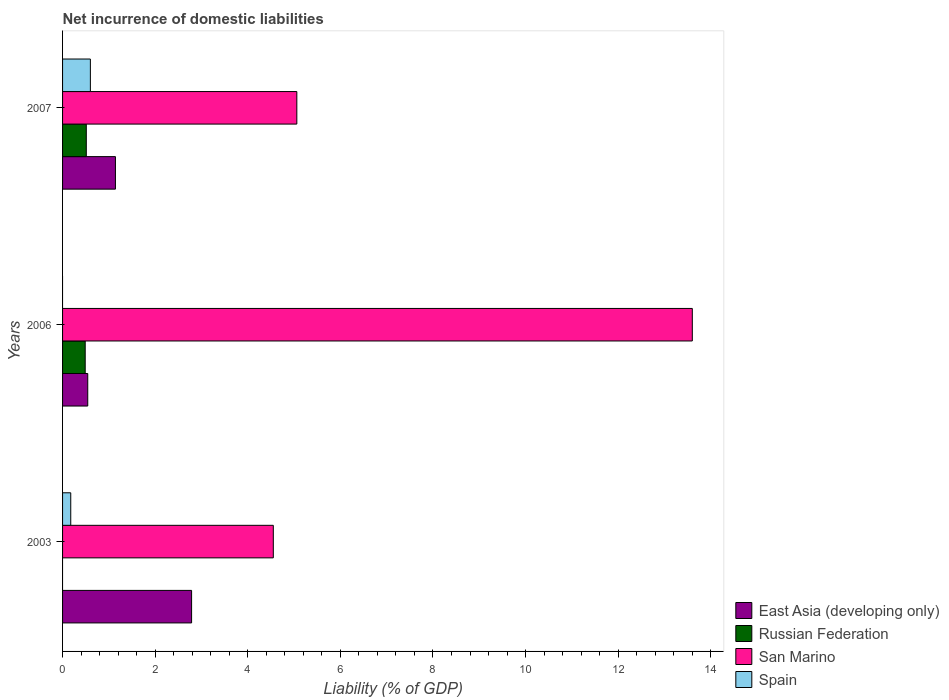How many different coloured bars are there?
Ensure brevity in your answer.  4. How many groups of bars are there?
Provide a short and direct response. 3. In how many cases, is the number of bars for a given year not equal to the number of legend labels?
Your answer should be very brief. 2. What is the net incurrence of domestic liabilities in San Marino in 2006?
Ensure brevity in your answer.  13.6. Across all years, what is the maximum net incurrence of domestic liabilities in Russian Federation?
Offer a terse response. 0.51. Across all years, what is the minimum net incurrence of domestic liabilities in San Marino?
Your answer should be very brief. 4.55. What is the total net incurrence of domestic liabilities in Russian Federation in the graph?
Your answer should be compact. 1. What is the difference between the net incurrence of domestic liabilities in Spain in 2003 and that in 2007?
Give a very brief answer. -0.42. What is the difference between the net incurrence of domestic liabilities in East Asia (developing only) in 2006 and the net incurrence of domestic liabilities in Russian Federation in 2007?
Your answer should be very brief. 0.03. What is the average net incurrence of domestic liabilities in East Asia (developing only) per year?
Offer a very short reply. 1.49. In the year 2006, what is the difference between the net incurrence of domestic liabilities in San Marino and net incurrence of domestic liabilities in Russian Federation?
Your response must be concise. 13.11. What is the ratio of the net incurrence of domestic liabilities in East Asia (developing only) in 2003 to that in 2006?
Make the answer very short. 5.12. Is the net incurrence of domestic liabilities in San Marino in 2003 less than that in 2006?
Your answer should be compact. Yes. Is the difference between the net incurrence of domestic liabilities in San Marino in 2006 and 2007 greater than the difference between the net incurrence of domestic liabilities in Russian Federation in 2006 and 2007?
Your answer should be very brief. Yes. What is the difference between the highest and the second highest net incurrence of domestic liabilities in San Marino?
Offer a terse response. 8.54. What is the difference between the highest and the lowest net incurrence of domestic liabilities in Russian Federation?
Ensure brevity in your answer.  0.51. In how many years, is the net incurrence of domestic liabilities in San Marino greater than the average net incurrence of domestic liabilities in San Marino taken over all years?
Make the answer very short. 1. Is the sum of the net incurrence of domestic liabilities in San Marino in 2003 and 2007 greater than the maximum net incurrence of domestic liabilities in Spain across all years?
Give a very brief answer. Yes. Are all the bars in the graph horizontal?
Provide a succinct answer. Yes. Are the values on the major ticks of X-axis written in scientific E-notation?
Make the answer very short. No. Where does the legend appear in the graph?
Ensure brevity in your answer.  Bottom right. How many legend labels are there?
Make the answer very short. 4. What is the title of the graph?
Give a very brief answer. Net incurrence of domestic liabilities. Does "Cambodia" appear as one of the legend labels in the graph?
Keep it short and to the point. No. What is the label or title of the X-axis?
Your answer should be compact. Liability (% of GDP). What is the Liability (% of GDP) of East Asia (developing only) in 2003?
Your answer should be compact. 2.79. What is the Liability (% of GDP) in San Marino in 2003?
Keep it short and to the point. 4.55. What is the Liability (% of GDP) of Spain in 2003?
Provide a succinct answer. 0.18. What is the Liability (% of GDP) of East Asia (developing only) in 2006?
Make the answer very short. 0.54. What is the Liability (% of GDP) of Russian Federation in 2006?
Your response must be concise. 0.49. What is the Liability (% of GDP) in San Marino in 2006?
Offer a terse response. 13.6. What is the Liability (% of GDP) of Spain in 2006?
Your response must be concise. 0. What is the Liability (% of GDP) of East Asia (developing only) in 2007?
Offer a terse response. 1.14. What is the Liability (% of GDP) of Russian Federation in 2007?
Your answer should be very brief. 0.51. What is the Liability (% of GDP) of San Marino in 2007?
Provide a succinct answer. 5.06. What is the Liability (% of GDP) in Spain in 2007?
Offer a very short reply. 0.6. Across all years, what is the maximum Liability (% of GDP) in East Asia (developing only)?
Your answer should be very brief. 2.79. Across all years, what is the maximum Liability (% of GDP) of Russian Federation?
Your response must be concise. 0.51. Across all years, what is the maximum Liability (% of GDP) in San Marino?
Your response must be concise. 13.6. Across all years, what is the maximum Liability (% of GDP) in Spain?
Keep it short and to the point. 0.6. Across all years, what is the minimum Liability (% of GDP) in East Asia (developing only)?
Keep it short and to the point. 0.54. Across all years, what is the minimum Liability (% of GDP) of Russian Federation?
Offer a very short reply. 0. Across all years, what is the minimum Liability (% of GDP) of San Marino?
Make the answer very short. 4.55. What is the total Liability (% of GDP) in East Asia (developing only) in the graph?
Make the answer very short. 4.47. What is the total Liability (% of GDP) in San Marino in the graph?
Ensure brevity in your answer.  23.21. What is the total Liability (% of GDP) in Spain in the graph?
Your answer should be compact. 0.78. What is the difference between the Liability (% of GDP) of East Asia (developing only) in 2003 and that in 2006?
Give a very brief answer. 2.24. What is the difference between the Liability (% of GDP) in San Marino in 2003 and that in 2006?
Ensure brevity in your answer.  -9.05. What is the difference between the Liability (% of GDP) of East Asia (developing only) in 2003 and that in 2007?
Offer a very short reply. 1.64. What is the difference between the Liability (% of GDP) in San Marino in 2003 and that in 2007?
Provide a short and direct response. -0.51. What is the difference between the Liability (% of GDP) in Spain in 2003 and that in 2007?
Keep it short and to the point. -0.42. What is the difference between the Liability (% of GDP) in East Asia (developing only) in 2006 and that in 2007?
Offer a terse response. -0.6. What is the difference between the Liability (% of GDP) in Russian Federation in 2006 and that in 2007?
Keep it short and to the point. -0.02. What is the difference between the Liability (% of GDP) in San Marino in 2006 and that in 2007?
Ensure brevity in your answer.  8.54. What is the difference between the Liability (% of GDP) of East Asia (developing only) in 2003 and the Liability (% of GDP) of Russian Federation in 2006?
Ensure brevity in your answer.  2.3. What is the difference between the Liability (% of GDP) of East Asia (developing only) in 2003 and the Liability (% of GDP) of San Marino in 2006?
Provide a succinct answer. -10.81. What is the difference between the Liability (% of GDP) in East Asia (developing only) in 2003 and the Liability (% of GDP) in Russian Federation in 2007?
Give a very brief answer. 2.27. What is the difference between the Liability (% of GDP) in East Asia (developing only) in 2003 and the Liability (% of GDP) in San Marino in 2007?
Provide a short and direct response. -2.27. What is the difference between the Liability (% of GDP) in East Asia (developing only) in 2003 and the Liability (% of GDP) in Spain in 2007?
Your answer should be compact. 2.19. What is the difference between the Liability (% of GDP) of San Marino in 2003 and the Liability (% of GDP) of Spain in 2007?
Your answer should be very brief. 3.95. What is the difference between the Liability (% of GDP) of East Asia (developing only) in 2006 and the Liability (% of GDP) of Russian Federation in 2007?
Give a very brief answer. 0.03. What is the difference between the Liability (% of GDP) of East Asia (developing only) in 2006 and the Liability (% of GDP) of San Marino in 2007?
Make the answer very short. -4.52. What is the difference between the Liability (% of GDP) in East Asia (developing only) in 2006 and the Liability (% of GDP) in Spain in 2007?
Your answer should be compact. -0.06. What is the difference between the Liability (% of GDP) in Russian Federation in 2006 and the Liability (% of GDP) in San Marino in 2007?
Make the answer very short. -4.57. What is the difference between the Liability (% of GDP) of Russian Federation in 2006 and the Liability (% of GDP) of Spain in 2007?
Your answer should be compact. -0.11. What is the difference between the Liability (% of GDP) of San Marino in 2006 and the Liability (% of GDP) of Spain in 2007?
Ensure brevity in your answer.  13. What is the average Liability (% of GDP) in East Asia (developing only) per year?
Keep it short and to the point. 1.49. What is the average Liability (% of GDP) in Russian Federation per year?
Provide a succinct answer. 0.33. What is the average Liability (% of GDP) of San Marino per year?
Your answer should be compact. 7.74. What is the average Liability (% of GDP) in Spain per year?
Provide a short and direct response. 0.26. In the year 2003, what is the difference between the Liability (% of GDP) in East Asia (developing only) and Liability (% of GDP) in San Marino?
Offer a terse response. -1.76. In the year 2003, what is the difference between the Liability (% of GDP) of East Asia (developing only) and Liability (% of GDP) of Spain?
Offer a very short reply. 2.61. In the year 2003, what is the difference between the Liability (% of GDP) of San Marino and Liability (% of GDP) of Spain?
Your answer should be very brief. 4.37. In the year 2006, what is the difference between the Liability (% of GDP) in East Asia (developing only) and Liability (% of GDP) in Russian Federation?
Keep it short and to the point. 0.06. In the year 2006, what is the difference between the Liability (% of GDP) of East Asia (developing only) and Liability (% of GDP) of San Marino?
Your answer should be compact. -13.06. In the year 2006, what is the difference between the Liability (% of GDP) of Russian Federation and Liability (% of GDP) of San Marino?
Provide a short and direct response. -13.11. In the year 2007, what is the difference between the Liability (% of GDP) of East Asia (developing only) and Liability (% of GDP) of Russian Federation?
Your answer should be compact. 0.63. In the year 2007, what is the difference between the Liability (% of GDP) in East Asia (developing only) and Liability (% of GDP) in San Marino?
Offer a very short reply. -3.92. In the year 2007, what is the difference between the Liability (% of GDP) of East Asia (developing only) and Liability (% of GDP) of Spain?
Ensure brevity in your answer.  0.54. In the year 2007, what is the difference between the Liability (% of GDP) of Russian Federation and Liability (% of GDP) of San Marino?
Your answer should be compact. -4.55. In the year 2007, what is the difference between the Liability (% of GDP) of Russian Federation and Liability (% of GDP) of Spain?
Your response must be concise. -0.09. In the year 2007, what is the difference between the Liability (% of GDP) in San Marino and Liability (% of GDP) in Spain?
Ensure brevity in your answer.  4.46. What is the ratio of the Liability (% of GDP) of East Asia (developing only) in 2003 to that in 2006?
Your answer should be compact. 5.12. What is the ratio of the Liability (% of GDP) in San Marino in 2003 to that in 2006?
Ensure brevity in your answer.  0.33. What is the ratio of the Liability (% of GDP) in East Asia (developing only) in 2003 to that in 2007?
Make the answer very short. 2.44. What is the ratio of the Liability (% of GDP) in San Marino in 2003 to that in 2007?
Your response must be concise. 0.9. What is the ratio of the Liability (% of GDP) of Spain in 2003 to that in 2007?
Ensure brevity in your answer.  0.29. What is the ratio of the Liability (% of GDP) in East Asia (developing only) in 2006 to that in 2007?
Provide a short and direct response. 0.48. What is the ratio of the Liability (% of GDP) in Russian Federation in 2006 to that in 2007?
Make the answer very short. 0.95. What is the ratio of the Liability (% of GDP) in San Marino in 2006 to that in 2007?
Your answer should be very brief. 2.69. What is the difference between the highest and the second highest Liability (% of GDP) of East Asia (developing only)?
Provide a short and direct response. 1.64. What is the difference between the highest and the second highest Liability (% of GDP) of San Marino?
Offer a terse response. 8.54. What is the difference between the highest and the lowest Liability (% of GDP) of East Asia (developing only)?
Provide a succinct answer. 2.24. What is the difference between the highest and the lowest Liability (% of GDP) in Russian Federation?
Keep it short and to the point. 0.51. What is the difference between the highest and the lowest Liability (% of GDP) in San Marino?
Keep it short and to the point. 9.05. What is the difference between the highest and the lowest Liability (% of GDP) of Spain?
Ensure brevity in your answer.  0.6. 